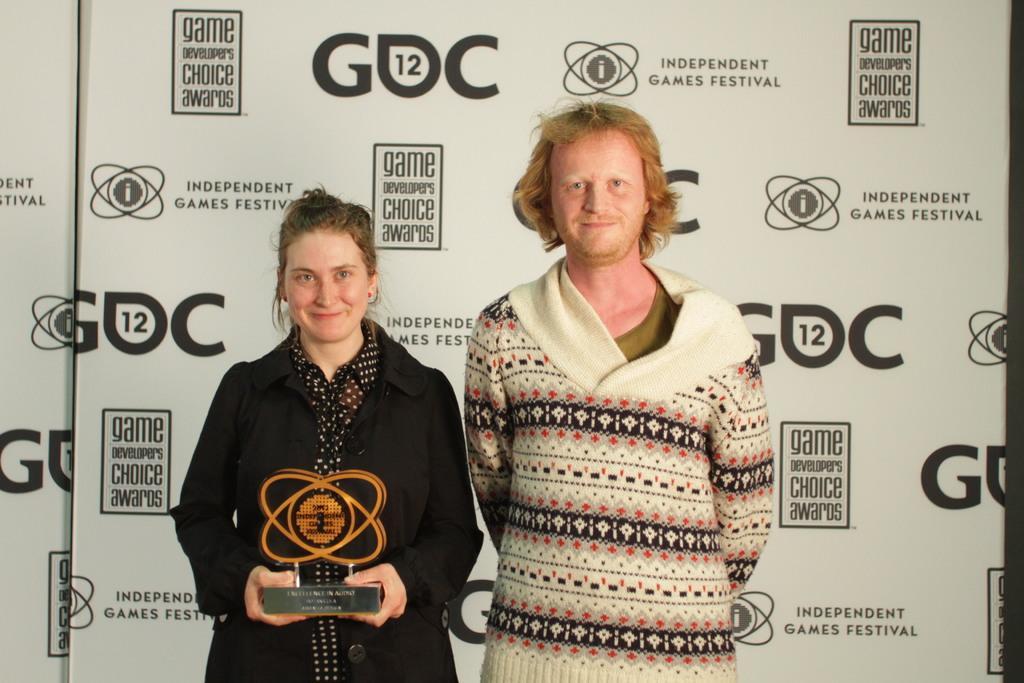Describe this image in one or two sentences. In this picture there is a man wearing white color sweater standing and giving a pose into the camera. Beside there is woman wearing black color coat, Smiling and holding award in the hand. In the background there is a white color advertisement banner. 